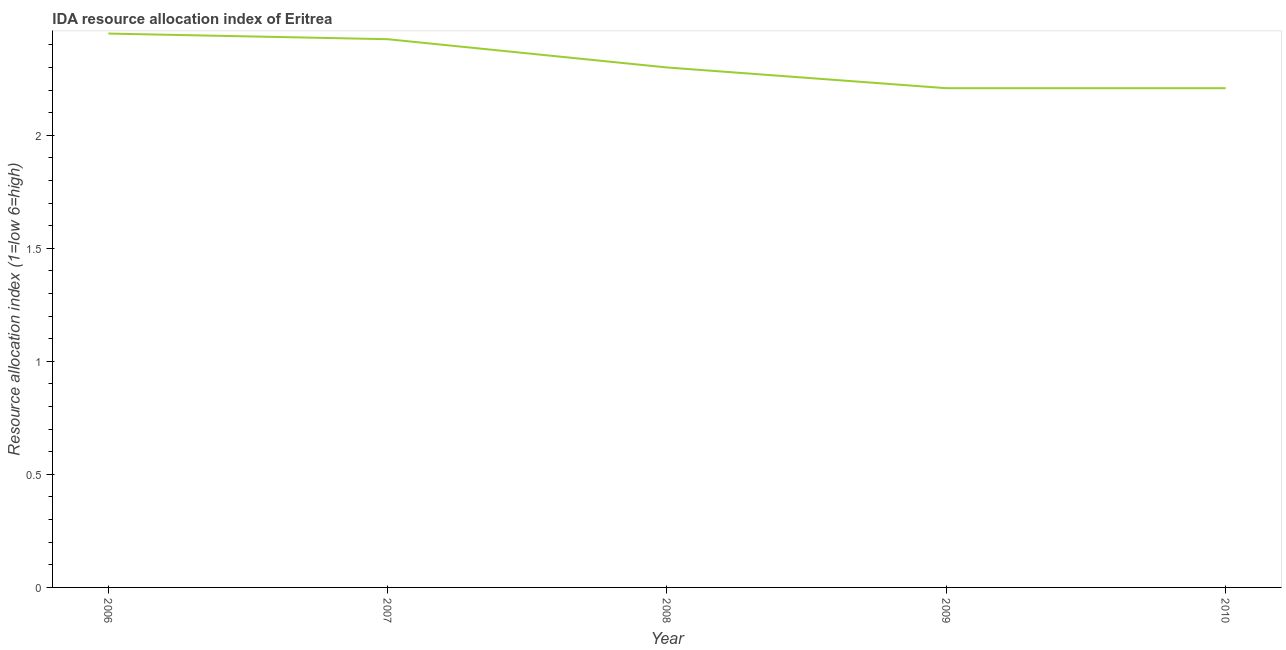What is the ida resource allocation index in 2007?
Give a very brief answer. 2.42. Across all years, what is the maximum ida resource allocation index?
Give a very brief answer. 2.45. Across all years, what is the minimum ida resource allocation index?
Offer a terse response. 2.21. In which year was the ida resource allocation index maximum?
Your answer should be compact. 2006. What is the sum of the ida resource allocation index?
Offer a very short reply. 11.59. What is the difference between the ida resource allocation index in 2008 and 2009?
Give a very brief answer. 0.09. What is the average ida resource allocation index per year?
Provide a short and direct response. 2.32. What is the median ida resource allocation index?
Make the answer very short. 2.3. In how many years, is the ida resource allocation index greater than 2.2 ?
Provide a succinct answer. 5. What is the ratio of the ida resource allocation index in 2006 to that in 2008?
Your response must be concise. 1.07. Is the ida resource allocation index in 2008 less than that in 2010?
Offer a terse response. No. Is the difference between the ida resource allocation index in 2006 and 2007 greater than the difference between any two years?
Ensure brevity in your answer.  No. What is the difference between the highest and the second highest ida resource allocation index?
Ensure brevity in your answer.  0.03. Is the sum of the ida resource allocation index in 2006 and 2008 greater than the maximum ida resource allocation index across all years?
Keep it short and to the point. Yes. What is the difference between the highest and the lowest ida resource allocation index?
Provide a succinct answer. 0.24. How many lines are there?
Offer a very short reply. 1. How many years are there in the graph?
Make the answer very short. 5. Are the values on the major ticks of Y-axis written in scientific E-notation?
Make the answer very short. No. What is the title of the graph?
Your answer should be very brief. IDA resource allocation index of Eritrea. What is the label or title of the X-axis?
Your answer should be compact. Year. What is the label or title of the Y-axis?
Keep it short and to the point. Resource allocation index (1=low 6=high). What is the Resource allocation index (1=low 6=high) in 2006?
Keep it short and to the point. 2.45. What is the Resource allocation index (1=low 6=high) of 2007?
Give a very brief answer. 2.42. What is the Resource allocation index (1=low 6=high) of 2008?
Give a very brief answer. 2.3. What is the Resource allocation index (1=low 6=high) of 2009?
Keep it short and to the point. 2.21. What is the Resource allocation index (1=low 6=high) of 2010?
Offer a very short reply. 2.21. What is the difference between the Resource allocation index (1=low 6=high) in 2006 and 2007?
Keep it short and to the point. 0.03. What is the difference between the Resource allocation index (1=low 6=high) in 2006 and 2009?
Keep it short and to the point. 0.24. What is the difference between the Resource allocation index (1=low 6=high) in 2006 and 2010?
Keep it short and to the point. 0.24. What is the difference between the Resource allocation index (1=low 6=high) in 2007 and 2008?
Your answer should be very brief. 0.12. What is the difference between the Resource allocation index (1=low 6=high) in 2007 and 2009?
Give a very brief answer. 0.22. What is the difference between the Resource allocation index (1=low 6=high) in 2007 and 2010?
Your answer should be very brief. 0.22. What is the difference between the Resource allocation index (1=low 6=high) in 2008 and 2009?
Ensure brevity in your answer.  0.09. What is the difference between the Resource allocation index (1=low 6=high) in 2008 and 2010?
Make the answer very short. 0.09. What is the ratio of the Resource allocation index (1=low 6=high) in 2006 to that in 2008?
Offer a very short reply. 1.06. What is the ratio of the Resource allocation index (1=low 6=high) in 2006 to that in 2009?
Make the answer very short. 1.11. What is the ratio of the Resource allocation index (1=low 6=high) in 2006 to that in 2010?
Keep it short and to the point. 1.11. What is the ratio of the Resource allocation index (1=low 6=high) in 2007 to that in 2008?
Your response must be concise. 1.05. What is the ratio of the Resource allocation index (1=low 6=high) in 2007 to that in 2009?
Provide a short and direct response. 1.1. What is the ratio of the Resource allocation index (1=low 6=high) in 2007 to that in 2010?
Your answer should be very brief. 1.1. What is the ratio of the Resource allocation index (1=low 6=high) in 2008 to that in 2009?
Keep it short and to the point. 1.04. What is the ratio of the Resource allocation index (1=low 6=high) in 2008 to that in 2010?
Keep it short and to the point. 1.04. 